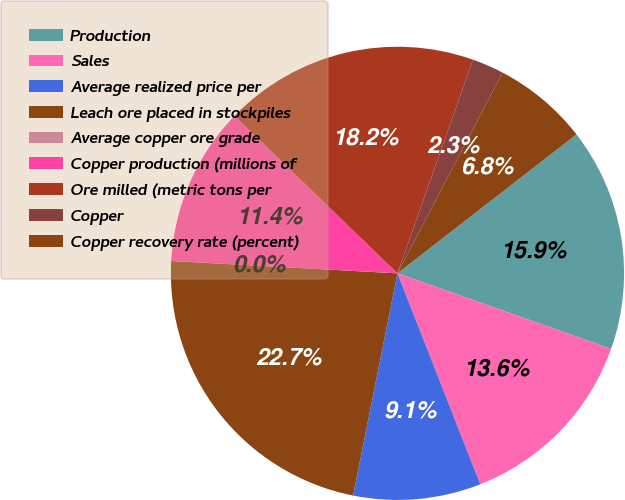Convert chart. <chart><loc_0><loc_0><loc_500><loc_500><pie_chart><fcel>Production<fcel>Sales<fcel>Average realized price per<fcel>Leach ore placed in stockpiles<fcel>Average copper ore grade<fcel>Copper production (millions of<fcel>Ore milled (metric tons per<fcel>Copper<fcel>Copper recovery rate (percent)<nl><fcel>15.91%<fcel>13.64%<fcel>9.09%<fcel>22.73%<fcel>0.0%<fcel>11.36%<fcel>18.18%<fcel>2.27%<fcel>6.82%<nl></chart> 